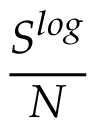<formula> <loc_0><loc_0><loc_500><loc_500>\frac { S ^ { \log } } { N }</formula> 